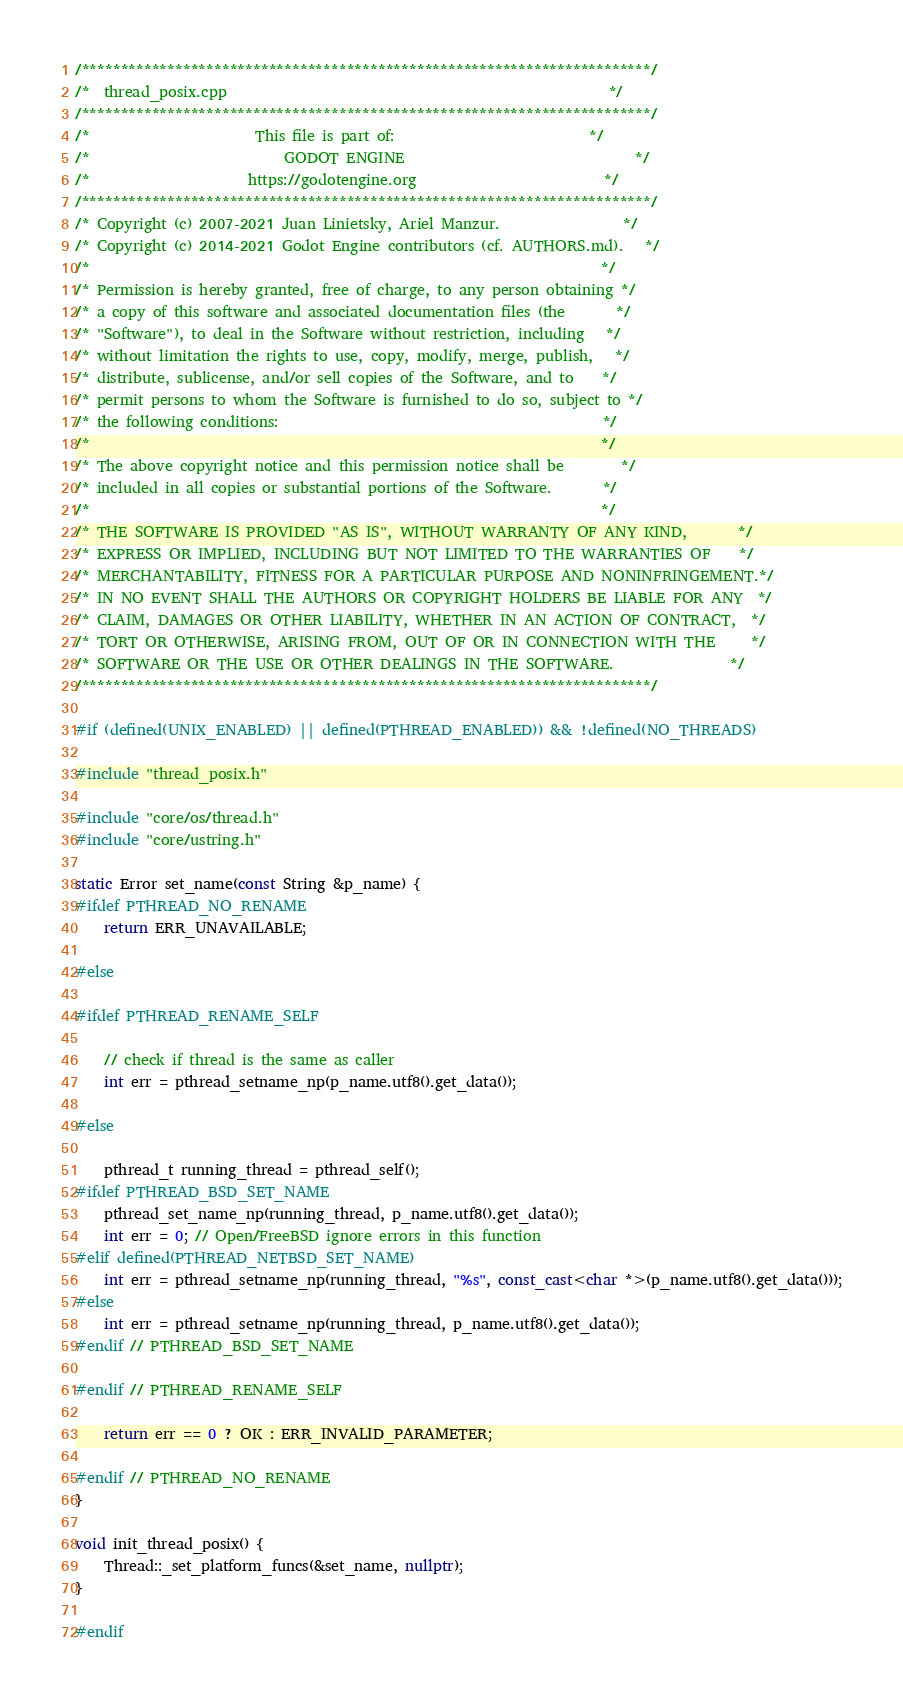<code> <loc_0><loc_0><loc_500><loc_500><_C++_>/*************************************************************************/
/*  thread_posix.cpp                                                     */
/*************************************************************************/
/*                       This file is part of:                           */
/*                           GODOT ENGINE                                */
/*                      https://godotengine.org                          */
/*************************************************************************/
/* Copyright (c) 2007-2021 Juan Linietsky, Ariel Manzur.                 */
/* Copyright (c) 2014-2021 Godot Engine contributors (cf. AUTHORS.md).   */
/*                                                                       */
/* Permission is hereby granted, free of charge, to any person obtaining */
/* a copy of this software and associated documentation files (the       */
/* "Software"), to deal in the Software without restriction, including   */
/* without limitation the rights to use, copy, modify, merge, publish,   */
/* distribute, sublicense, and/or sell copies of the Software, and to    */
/* permit persons to whom the Software is furnished to do so, subject to */
/* the following conditions:                                             */
/*                                                                       */
/* The above copyright notice and this permission notice shall be        */
/* included in all copies or substantial portions of the Software.       */
/*                                                                       */
/* THE SOFTWARE IS PROVIDED "AS IS", WITHOUT WARRANTY OF ANY KIND,       */
/* EXPRESS OR IMPLIED, INCLUDING BUT NOT LIMITED TO THE WARRANTIES OF    */
/* MERCHANTABILITY, FITNESS FOR A PARTICULAR PURPOSE AND NONINFRINGEMENT.*/
/* IN NO EVENT SHALL THE AUTHORS OR COPYRIGHT HOLDERS BE LIABLE FOR ANY  */
/* CLAIM, DAMAGES OR OTHER LIABILITY, WHETHER IN AN ACTION OF CONTRACT,  */
/* TORT OR OTHERWISE, ARISING FROM, OUT OF OR IN CONNECTION WITH THE     */
/* SOFTWARE OR THE USE OR OTHER DEALINGS IN THE SOFTWARE.                */
/*************************************************************************/

#if (defined(UNIX_ENABLED) || defined(PTHREAD_ENABLED)) && !defined(NO_THREADS)

#include "thread_posix.h"

#include "core/os/thread.h"
#include "core/ustring.h"

static Error set_name(const String &p_name) {
#ifdef PTHREAD_NO_RENAME
	return ERR_UNAVAILABLE;

#else

#ifdef PTHREAD_RENAME_SELF

	// check if thread is the same as caller
	int err = pthread_setname_np(p_name.utf8().get_data());

#else

	pthread_t running_thread = pthread_self();
#ifdef PTHREAD_BSD_SET_NAME
	pthread_set_name_np(running_thread, p_name.utf8().get_data());
	int err = 0; // Open/FreeBSD ignore errors in this function
#elif defined(PTHREAD_NETBSD_SET_NAME)
	int err = pthread_setname_np(running_thread, "%s", const_cast<char *>(p_name.utf8().get_data()));
#else
	int err = pthread_setname_np(running_thread, p_name.utf8().get_data());
#endif // PTHREAD_BSD_SET_NAME

#endif // PTHREAD_RENAME_SELF

	return err == 0 ? OK : ERR_INVALID_PARAMETER;

#endif // PTHREAD_NO_RENAME
}

void init_thread_posix() {
	Thread::_set_platform_funcs(&set_name, nullptr);
}

#endif
</code> 